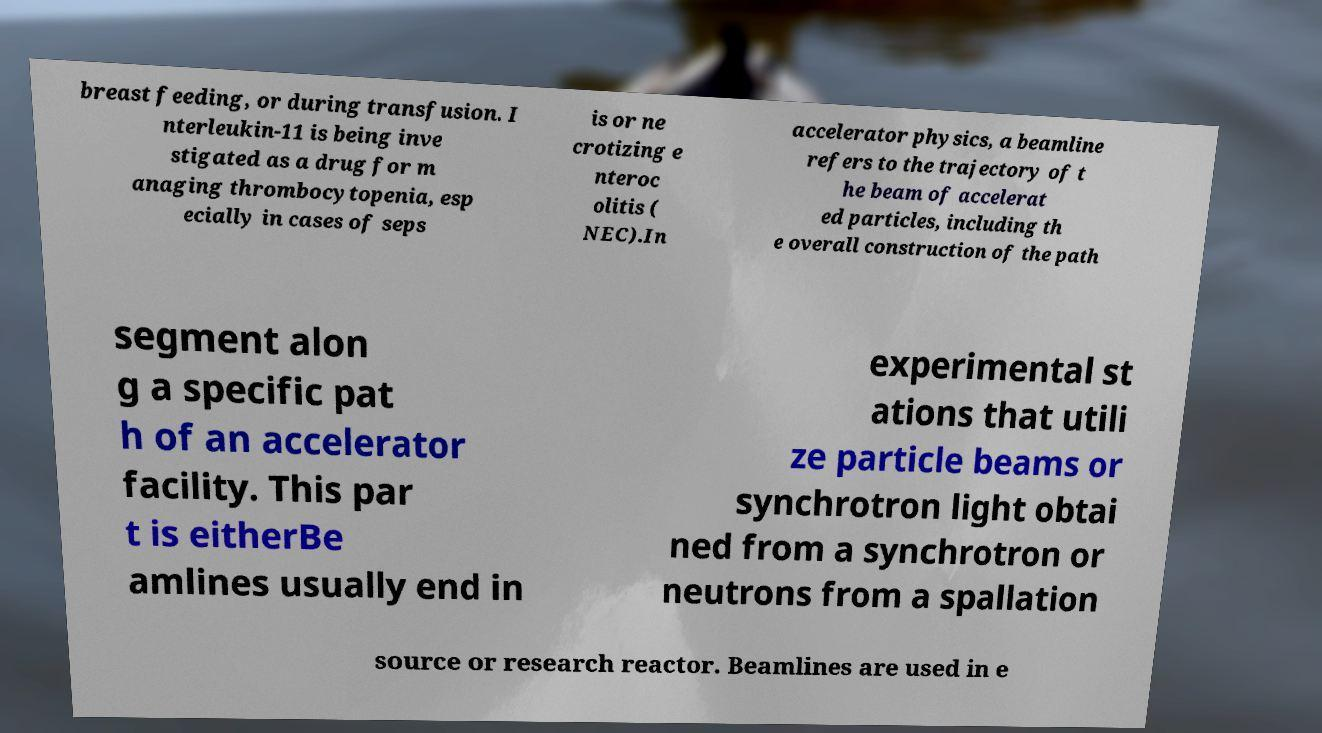Can you accurately transcribe the text from the provided image for me? breast feeding, or during transfusion. I nterleukin-11 is being inve stigated as a drug for m anaging thrombocytopenia, esp ecially in cases of seps is or ne crotizing e nteroc olitis ( NEC).In accelerator physics, a beamline refers to the trajectory of t he beam of accelerat ed particles, including th e overall construction of the path segment alon g a specific pat h of an accelerator facility. This par t is eitherBe amlines usually end in experimental st ations that utili ze particle beams or synchrotron light obtai ned from a synchrotron or neutrons from a spallation source or research reactor. Beamlines are used in e 